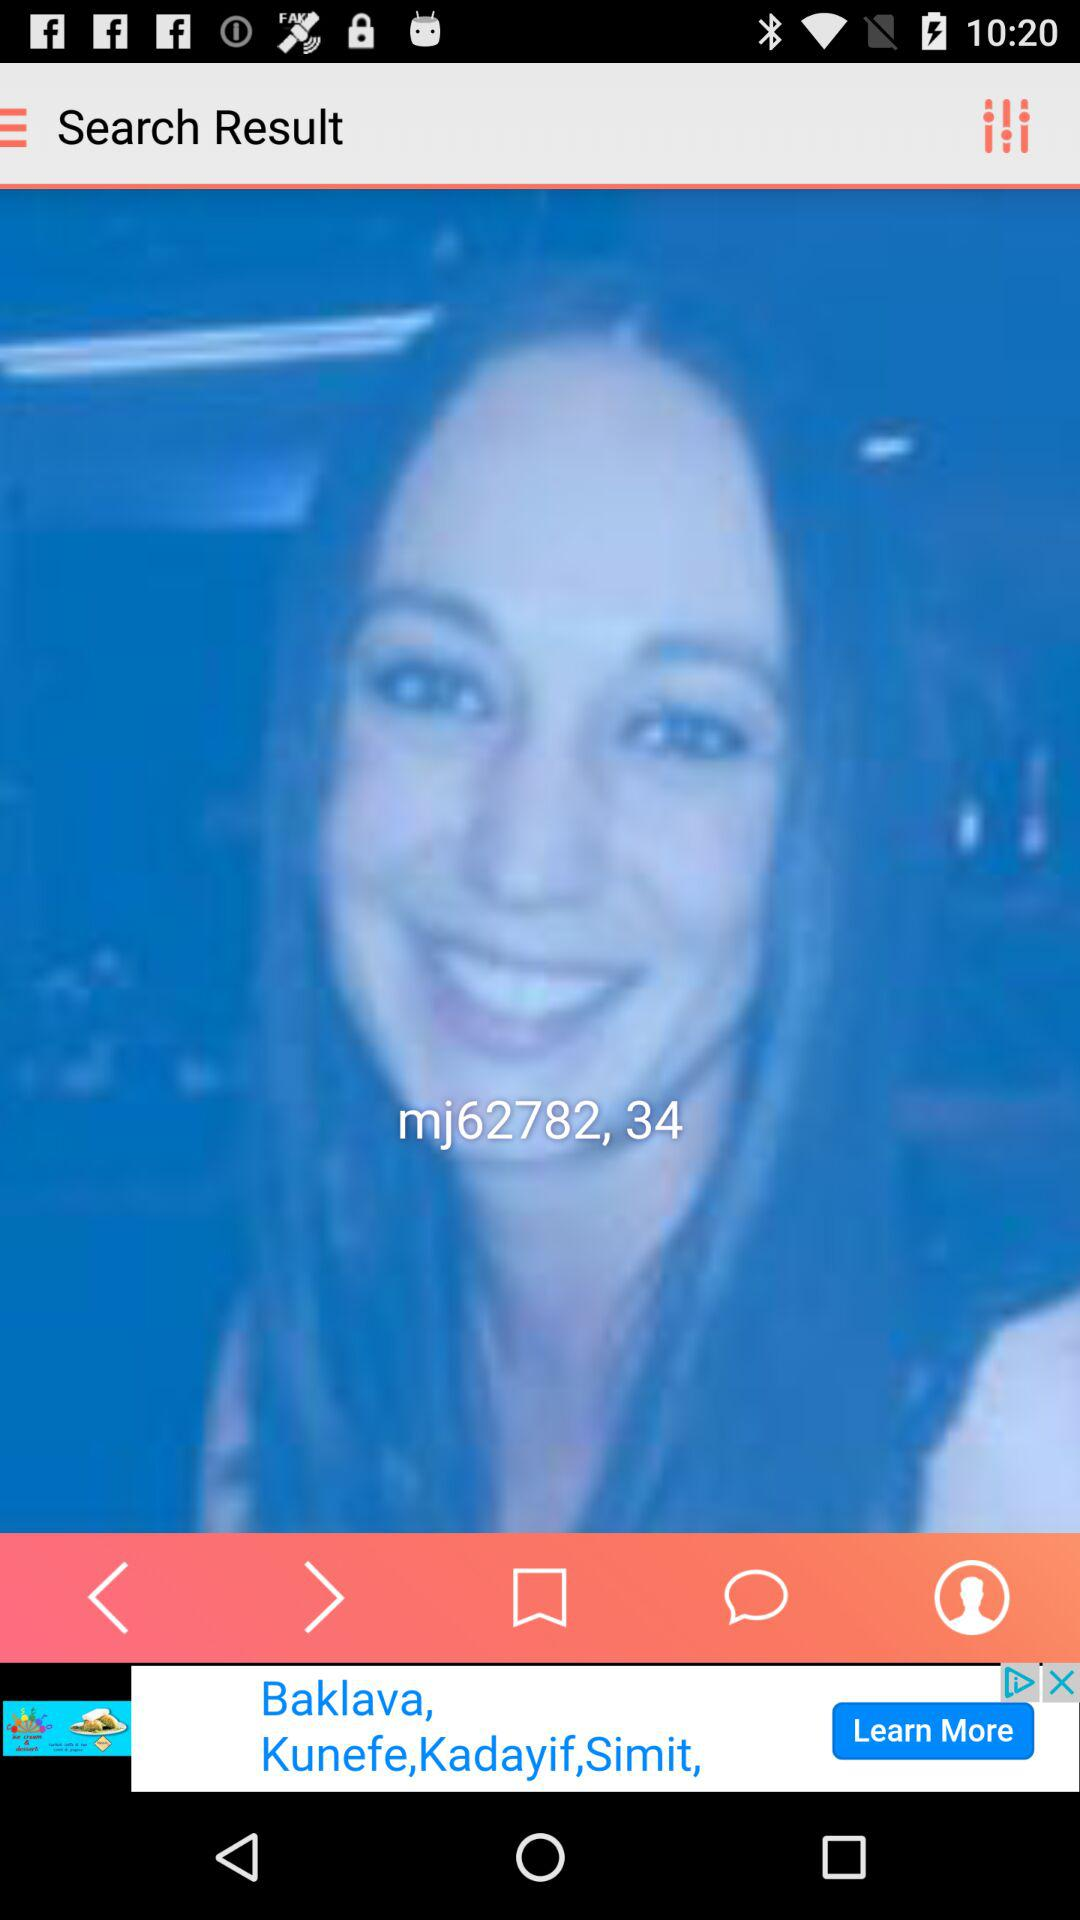What's mj62782's age? The age is 34 years. 